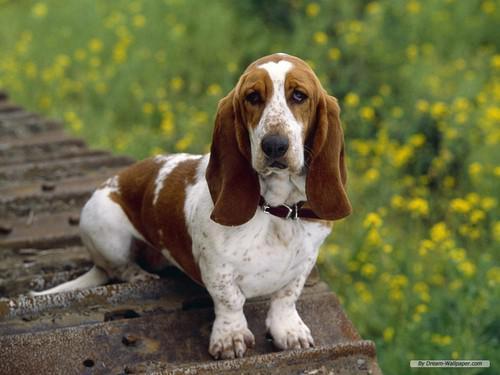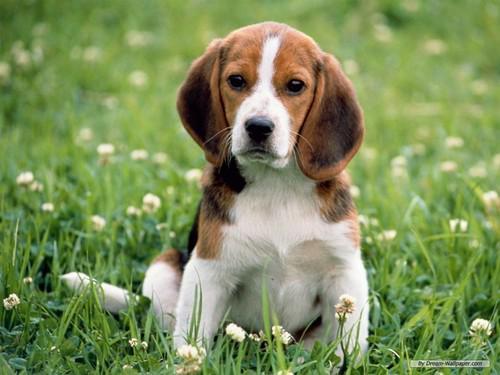The first image is the image on the left, the second image is the image on the right. Considering the images on both sides, is "One of the puppies is running through the grass." valid? Answer yes or no. No. 